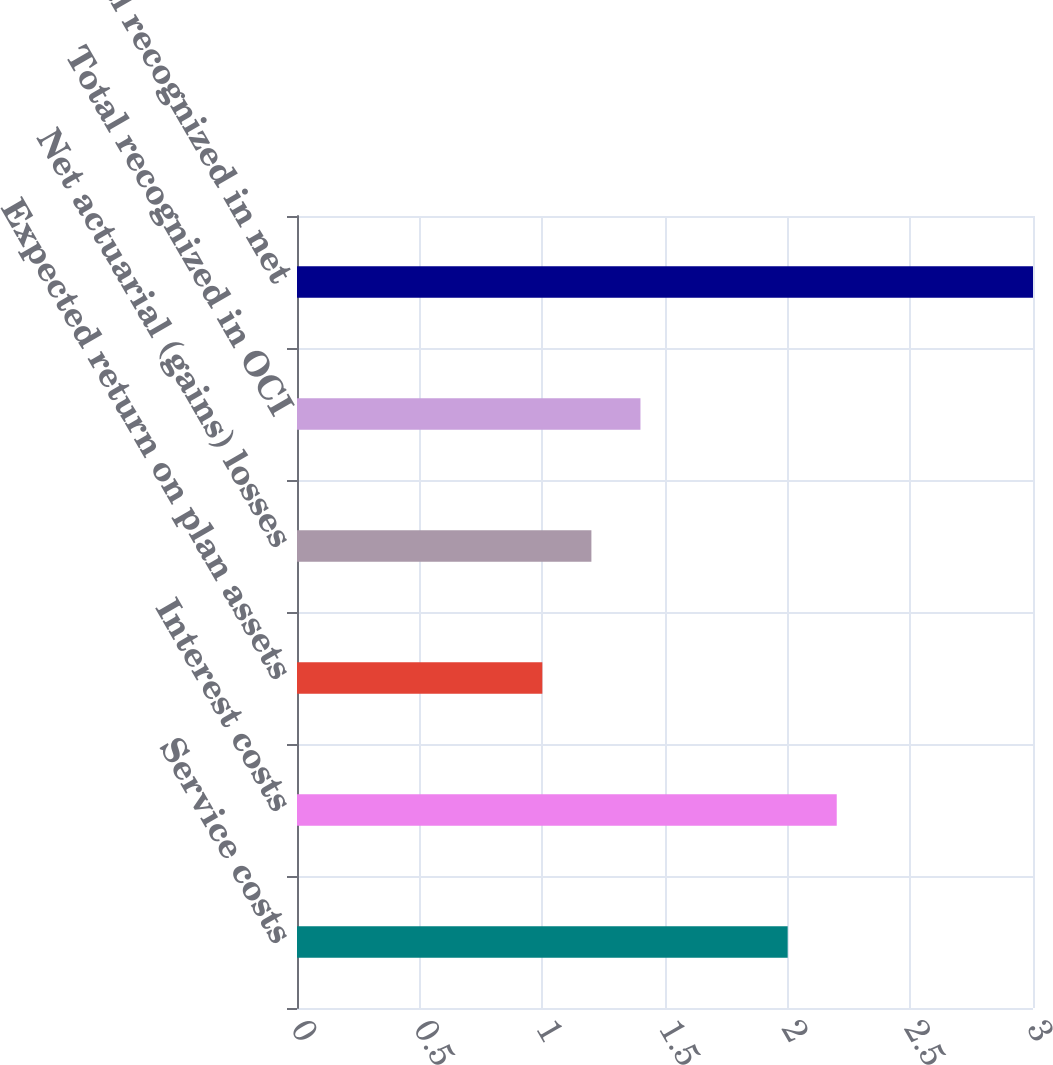Convert chart to OTSL. <chart><loc_0><loc_0><loc_500><loc_500><bar_chart><fcel>Service costs<fcel>Interest costs<fcel>Expected return on plan assets<fcel>Net actuarial (gains) losses<fcel>Total recognized in OCI<fcel>Total recognized in net<nl><fcel>2<fcel>2.2<fcel>1<fcel>1.2<fcel>1.4<fcel>3<nl></chart> 